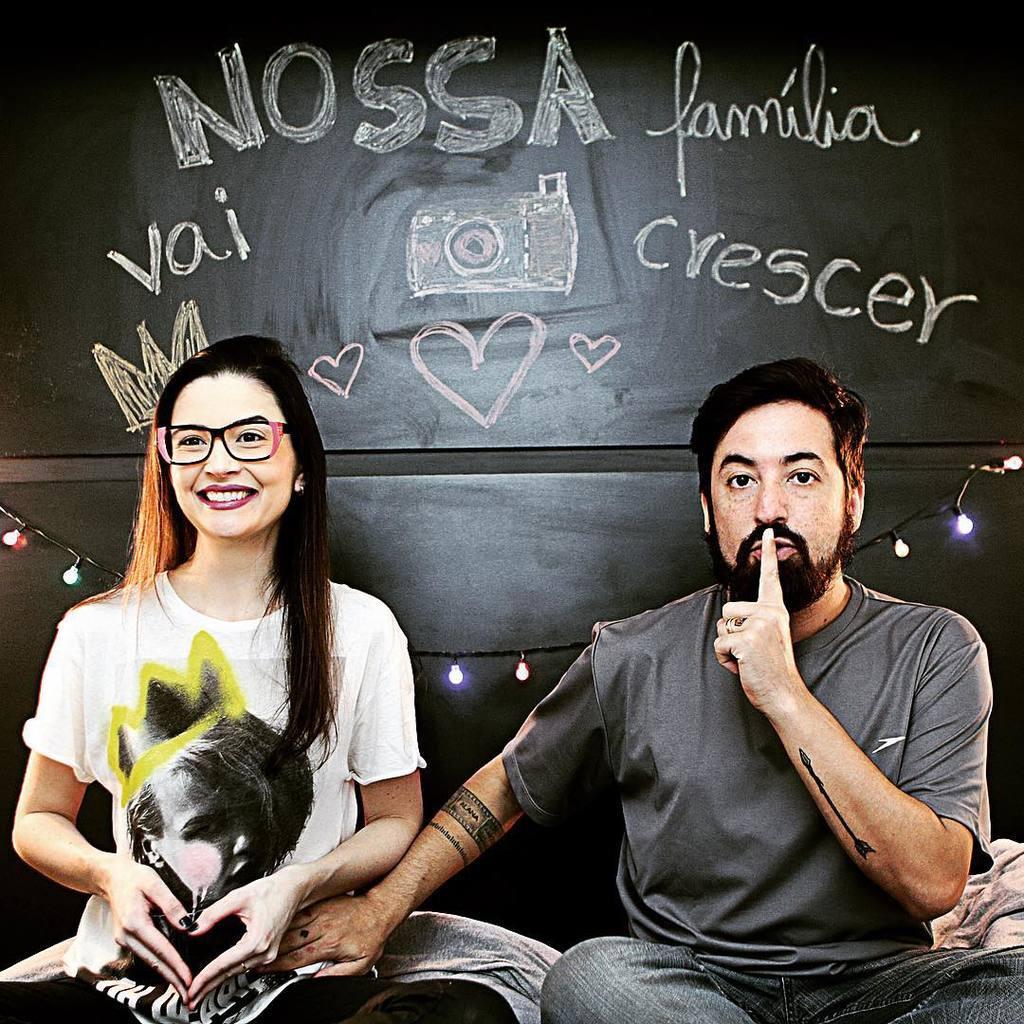How would you summarize this image in a sentence or two? In this picture we can see a woman wore a spectacle and smiling and beside her we can see a man and they both are sitting and in the background we can see the lights, wall with some text, symbols on it. 